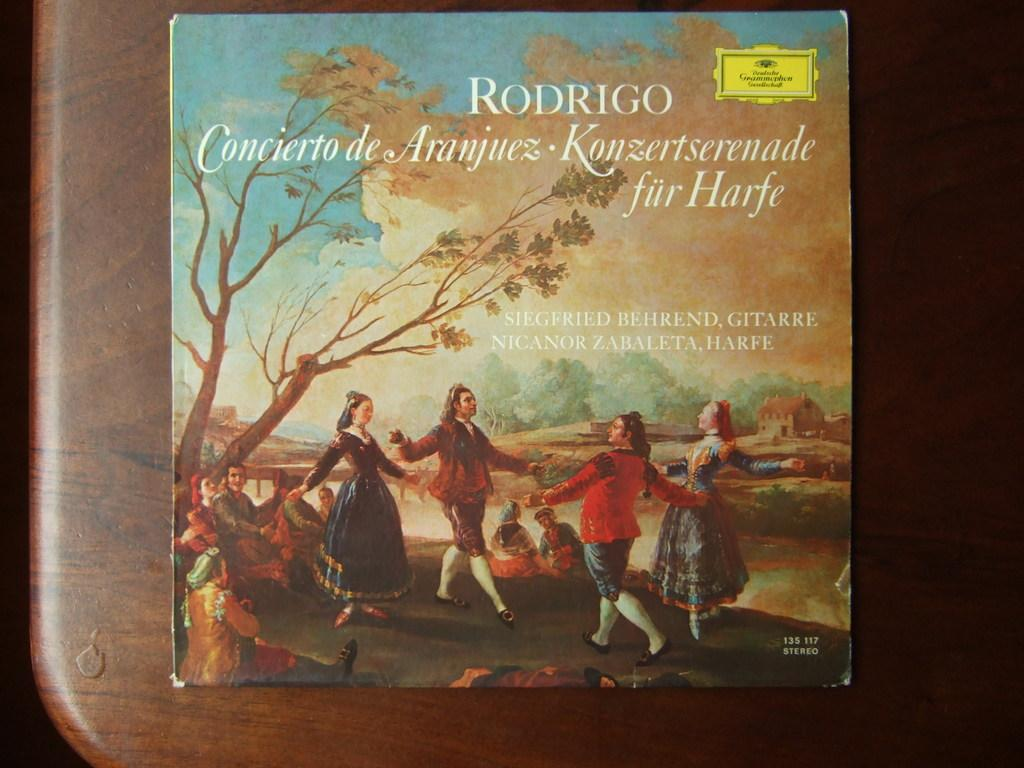<image>
Give a short and clear explanation of the subsequent image. The cover of a musical album called rodrigo with the rest of the text in french. 